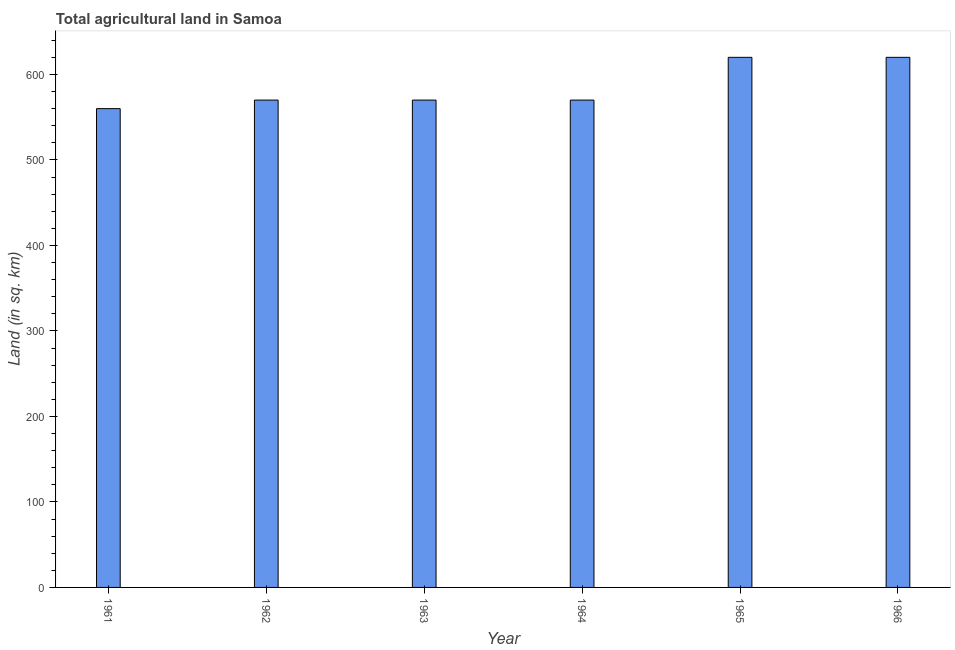Does the graph contain any zero values?
Your response must be concise. No. Does the graph contain grids?
Provide a short and direct response. No. What is the title of the graph?
Offer a terse response. Total agricultural land in Samoa. What is the label or title of the X-axis?
Give a very brief answer. Year. What is the label or title of the Y-axis?
Keep it short and to the point. Land (in sq. km). What is the agricultural land in 1963?
Offer a terse response. 570. Across all years, what is the maximum agricultural land?
Your response must be concise. 620. Across all years, what is the minimum agricultural land?
Give a very brief answer. 560. In which year was the agricultural land maximum?
Provide a succinct answer. 1965. What is the sum of the agricultural land?
Make the answer very short. 3510. What is the average agricultural land per year?
Your answer should be compact. 585. What is the median agricultural land?
Your answer should be compact. 570. In how many years, is the agricultural land greater than 240 sq. km?
Ensure brevity in your answer.  6. What is the ratio of the agricultural land in 1963 to that in 1965?
Make the answer very short. 0.92. Is the difference between the agricultural land in 1962 and 1965 greater than the difference between any two years?
Your response must be concise. No. What is the difference between the highest and the second highest agricultural land?
Your answer should be very brief. 0. In how many years, is the agricultural land greater than the average agricultural land taken over all years?
Your answer should be compact. 2. How many bars are there?
Make the answer very short. 6. What is the difference between two consecutive major ticks on the Y-axis?
Make the answer very short. 100. Are the values on the major ticks of Y-axis written in scientific E-notation?
Offer a very short reply. No. What is the Land (in sq. km) of 1961?
Give a very brief answer. 560. What is the Land (in sq. km) of 1962?
Provide a succinct answer. 570. What is the Land (in sq. km) of 1963?
Offer a terse response. 570. What is the Land (in sq. km) in 1964?
Provide a short and direct response. 570. What is the Land (in sq. km) in 1965?
Offer a terse response. 620. What is the Land (in sq. km) in 1966?
Ensure brevity in your answer.  620. What is the difference between the Land (in sq. km) in 1961 and 1962?
Your answer should be very brief. -10. What is the difference between the Land (in sq. km) in 1961 and 1963?
Ensure brevity in your answer.  -10. What is the difference between the Land (in sq. km) in 1961 and 1965?
Ensure brevity in your answer.  -60. What is the difference between the Land (in sq. km) in 1961 and 1966?
Your response must be concise. -60. What is the difference between the Land (in sq. km) in 1963 and 1964?
Ensure brevity in your answer.  0. What is the difference between the Land (in sq. km) in 1963 and 1966?
Offer a very short reply. -50. What is the difference between the Land (in sq. km) in 1964 and 1965?
Your answer should be very brief. -50. What is the difference between the Land (in sq. km) in 1964 and 1966?
Offer a terse response. -50. What is the difference between the Land (in sq. km) in 1965 and 1966?
Give a very brief answer. 0. What is the ratio of the Land (in sq. km) in 1961 to that in 1964?
Your response must be concise. 0.98. What is the ratio of the Land (in sq. km) in 1961 to that in 1965?
Offer a terse response. 0.9. What is the ratio of the Land (in sq. km) in 1961 to that in 1966?
Keep it short and to the point. 0.9. What is the ratio of the Land (in sq. km) in 1962 to that in 1965?
Make the answer very short. 0.92. What is the ratio of the Land (in sq. km) in 1962 to that in 1966?
Your answer should be very brief. 0.92. What is the ratio of the Land (in sq. km) in 1963 to that in 1964?
Your response must be concise. 1. What is the ratio of the Land (in sq. km) in 1963 to that in 1965?
Make the answer very short. 0.92. What is the ratio of the Land (in sq. km) in 1963 to that in 1966?
Your answer should be compact. 0.92. What is the ratio of the Land (in sq. km) in 1964 to that in 1965?
Make the answer very short. 0.92. What is the ratio of the Land (in sq. km) in 1964 to that in 1966?
Your answer should be compact. 0.92. 